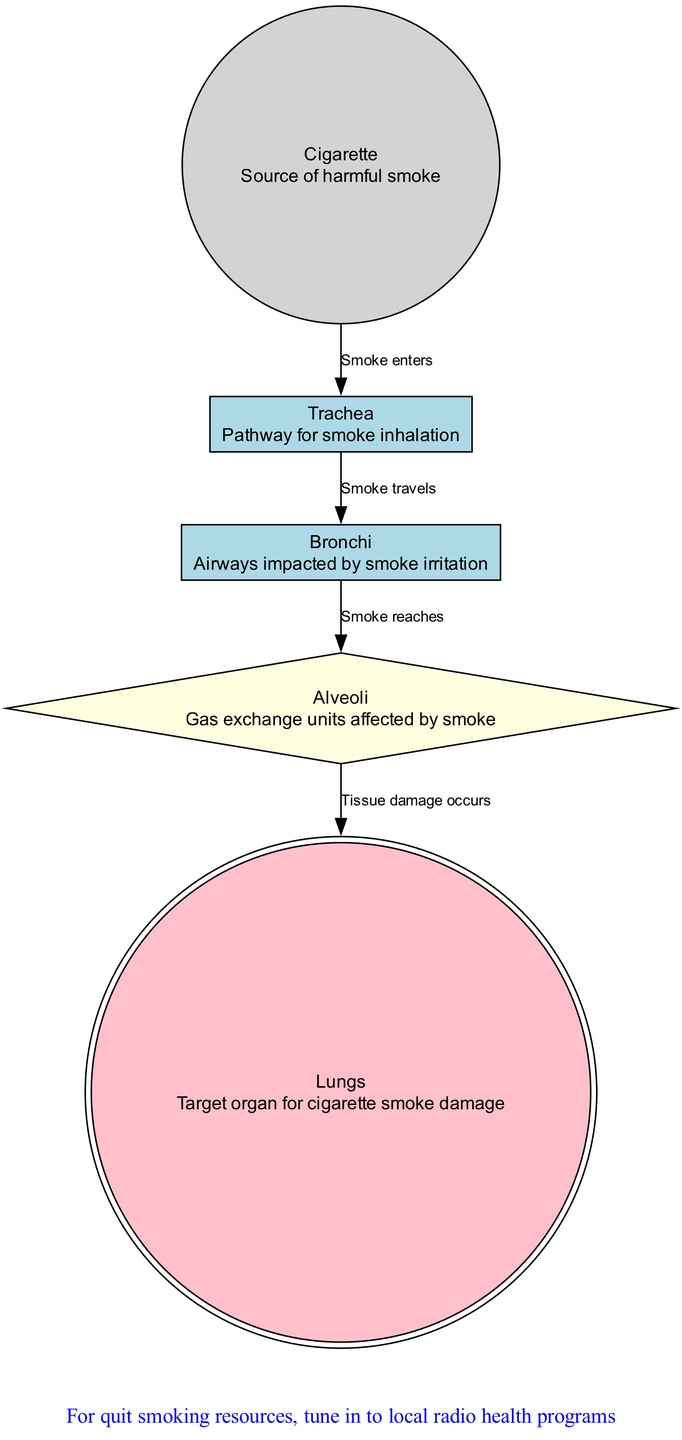What is the target organ for cigarette smoke damage? The diagram highlights that the "Lungs" is identified as the target organ for cigarette smoke damage. Reviewing node descriptions allows us to directly find this information.
Answer: Lungs How does smoke enter the respiratory system? The diagram indicates that smoke enters through the "Trachea," as shown by the edge coming from the "Cigarette" to the "Trachea." This direct connection gives us the answer.
Answer: Trachea What structure is impacted by smoke irritation? The "Bronchi" node explicitly describes being affected by smoke irritation. By examining the nodes, we can quickly identify this structure.
Answer: Bronchi How many nodes are present in the diagram? Counting the nodes represented in the diagram, we see five total: lungs, trachea, alveoli, bronchi, and cigarette. Thus, the total count is derived from these five distinct entities.
Answer: 5 What happens to the alveoli when smoke reaches them? The diagram specifies that "Tissue damage occurs" at the alveoli, highlighted by the edge leading to the lungs. By following the edges to this node, we understand its impact from the smoke.
Answer: Tissue damage occurs What is the last step in the pathway of smoke in the diagram? The last edge in the sequence is from "Alveoli" to "Lungs," indicating that the smoke ultimately leads to lung damage as a final step. Following the flow in the diagram gives this conclusive endpoint.
Answer: Lungs What is indicated at the top of the diagram? A warning message is displayed at the top: "Warning: Smoking damages your lungs." This annotation is prominently placed and serves as a crucial informational element of the diagram.
Answer: Warning: Smoking damages your lungs What type of programs are suggested for quitting smoking at the bottom of the diagram? The bottom annotation suggests tuning into "local radio health programs" for quitting smoking resources. This element connects to the marketing strategy of radio advertising that can promote health awareness.
Answer: local radio health programs 